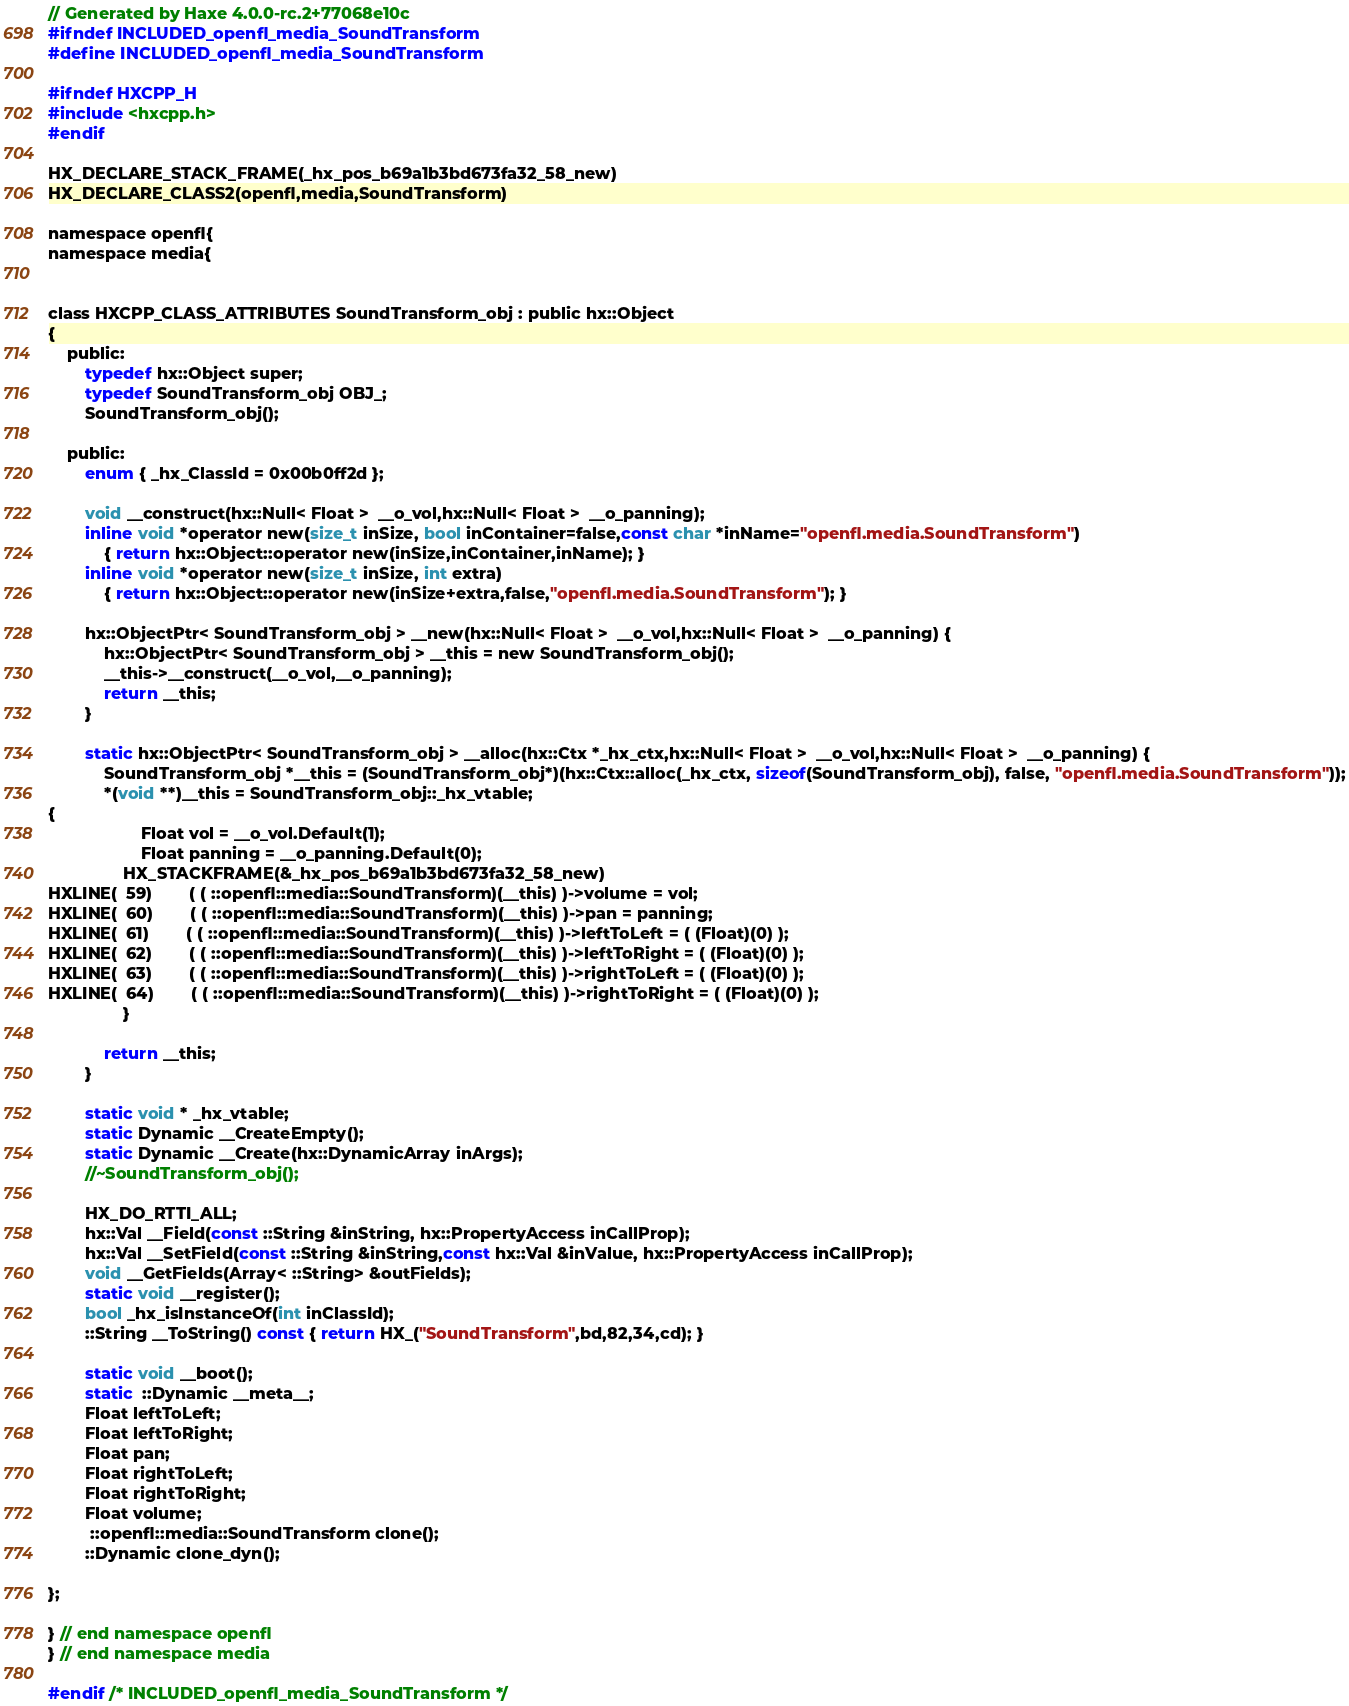Convert code to text. <code><loc_0><loc_0><loc_500><loc_500><_C_>// Generated by Haxe 4.0.0-rc.2+77068e10c
#ifndef INCLUDED_openfl_media_SoundTransform
#define INCLUDED_openfl_media_SoundTransform

#ifndef HXCPP_H
#include <hxcpp.h>
#endif

HX_DECLARE_STACK_FRAME(_hx_pos_b69a1b3bd673fa32_58_new)
HX_DECLARE_CLASS2(openfl,media,SoundTransform)

namespace openfl{
namespace media{


class HXCPP_CLASS_ATTRIBUTES SoundTransform_obj : public hx::Object
{
	public:
		typedef hx::Object super;
		typedef SoundTransform_obj OBJ_;
		SoundTransform_obj();

	public:
		enum { _hx_ClassId = 0x00b0ff2d };

		void __construct(hx::Null< Float >  __o_vol,hx::Null< Float >  __o_panning);
		inline void *operator new(size_t inSize, bool inContainer=false,const char *inName="openfl.media.SoundTransform")
			{ return hx::Object::operator new(inSize,inContainer,inName); }
		inline void *operator new(size_t inSize, int extra)
			{ return hx::Object::operator new(inSize+extra,false,"openfl.media.SoundTransform"); }

		hx::ObjectPtr< SoundTransform_obj > __new(hx::Null< Float >  __o_vol,hx::Null< Float >  __o_panning) {
			hx::ObjectPtr< SoundTransform_obj > __this = new SoundTransform_obj();
			__this->__construct(__o_vol,__o_panning);
			return __this;
		}

		static hx::ObjectPtr< SoundTransform_obj > __alloc(hx::Ctx *_hx_ctx,hx::Null< Float >  __o_vol,hx::Null< Float >  __o_panning) {
			SoundTransform_obj *__this = (SoundTransform_obj*)(hx::Ctx::alloc(_hx_ctx, sizeof(SoundTransform_obj), false, "openfl.media.SoundTransform"));
			*(void **)__this = SoundTransform_obj::_hx_vtable;
{
            		Float vol = __o_vol.Default(1);
            		Float panning = __o_panning.Default(0);
            	HX_STACKFRAME(&_hx_pos_b69a1b3bd673fa32_58_new)
HXLINE(  59)		( ( ::openfl::media::SoundTransform)(__this) )->volume = vol;
HXLINE(  60)		( ( ::openfl::media::SoundTransform)(__this) )->pan = panning;
HXLINE(  61)		( ( ::openfl::media::SoundTransform)(__this) )->leftToLeft = ( (Float)(0) );
HXLINE(  62)		( ( ::openfl::media::SoundTransform)(__this) )->leftToRight = ( (Float)(0) );
HXLINE(  63)		( ( ::openfl::media::SoundTransform)(__this) )->rightToLeft = ( (Float)(0) );
HXLINE(  64)		( ( ::openfl::media::SoundTransform)(__this) )->rightToRight = ( (Float)(0) );
            	}
		
			return __this;
		}

		static void * _hx_vtable;
		static Dynamic __CreateEmpty();
		static Dynamic __Create(hx::DynamicArray inArgs);
		//~SoundTransform_obj();

		HX_DO_RTTI_ALL;
		hx::Val __Field(const ::String &inString, hx::PropertyAccess inCallProp);
		hx::Val __SetField(const ::String &inString,const hx::Val &inValue, hx::PropertyAccess inCallProp);
		void __GetFields(Array< ::String> &outFields);
		static void __register();
		bool _hx_isInstanceOf(int inClassId);
		::String __ToString() const { return HX_("SoundTransform",bd,82,34,cd); }

		static void __boot();
		static  ::Dynamic __meta__;
		Float leftToLeft;
		Float leftToRight;
		Float pan;
		Float rightToLeft;
		Float rightToRight;
		Float volume;
		 ::openfl::media::SoundTransform clone();
		::Dynamic clone_dyn();

};

} // end namespace openfl
} // end namespace media

#endif /* INCLUDED_openfl_media_SoundTransform */ 
</code> 